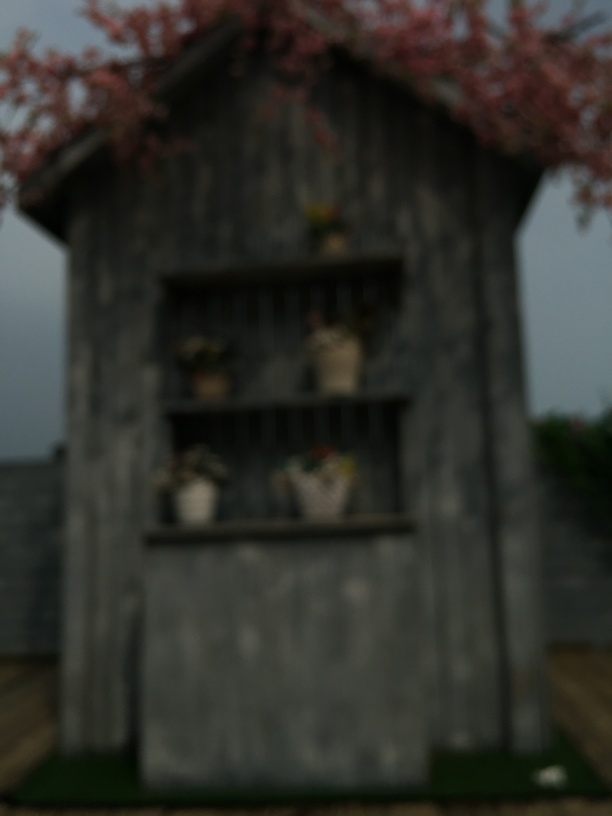Can you describe the surroundings of the building? The image is too blurry to provide detailed observations, but it seems to be surrounded by greenery that could indicate a rural or garden setting, and there's a reddish hue at the top that might suggest flowering trees or plants nearby. 